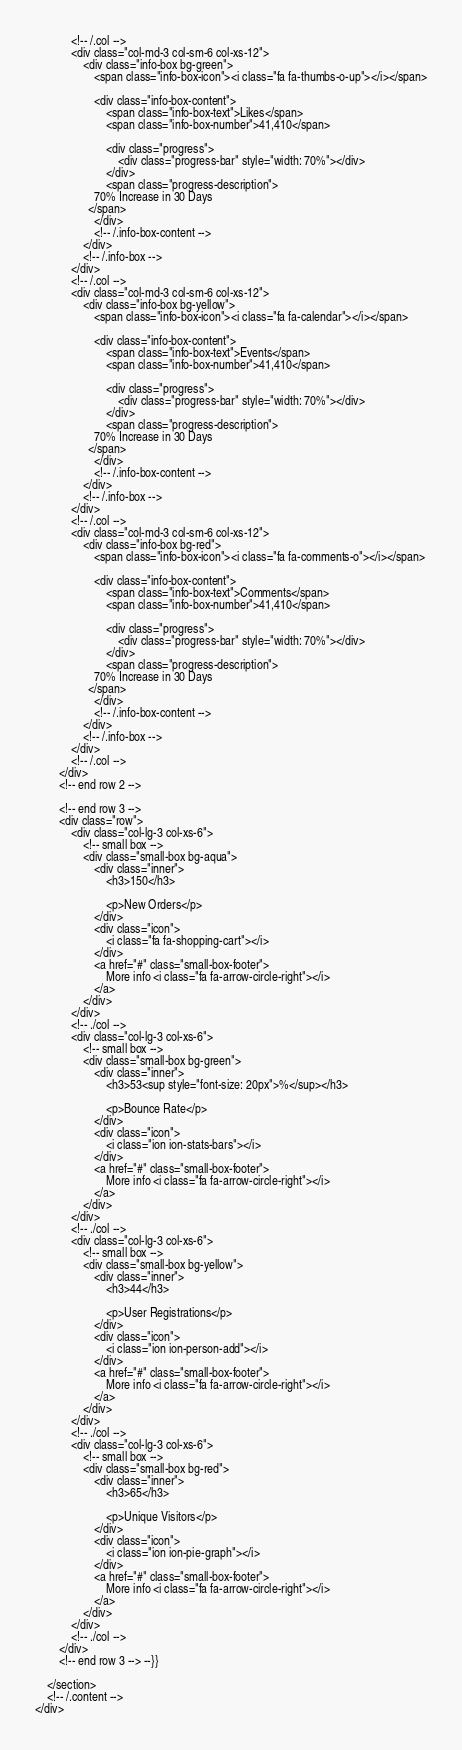<code> <loc_0><loc_0><loc_500><loc_500><_PHP_>            <!-- /.col -->
            <div class="col-md-3 col-sm-6 col-xs-12">
                <div class="info-box bg-green">
                    <span class="info-box-icon"><i class="fa fa-thumbs-o-up"></i></span>

                    <div class="info-box-content">
                        <span class="info-box-text">Likes</span>
                        <span class="info-box-number">41,410</span>

                        <div class="progress">
                            <div class="progress-bar" style="width: 70%"></div>
                        </div>
                        <span class="progress-description">
                    70% Increase in 30 Days
                  </span>
                    </div>
                    <!-- /.info-box-content -->
                </div>
                <!-- /.info-box -->
            </div>
            <!-- /.col -->
            <div class="col-md-3 col-sm-6 col-xs-12">
                <div class="info-box bg-yellow">
                    <span class="info-box-icon"><i class="fa fa-calendar"></i></span>

                    <div class="info-box-content">
                        <span class="info-box-text">Events</span>
                        <span class="info-box-number">41,410</span>

                        <div class="progress">
                            <div class="progress-bar" style="width: 70%"></div>
                        </div>
                        <span class="progress-description">
                    70% Increase in 30 Days
                  </span>
                    </div>
                    <!-- /.info-box-content -->
                </div>
                <!-- /.info-box -->
            </div>
            <!-- /.col -->
            <div class="col-md-3 col-sm-6 col-xs-12">
                <div class="info-box bg-red">
                    <span class="info-box-icon"><i class="fa fa-comments-o"></i></span>

                    <div class="info-box-content">
                        <span class="info-box-text">Comments</span>
                        <span class="info-box-number">41,410</span>

                        <div class="progress">
                            <div class="progress-bar" style="width: 70%"></div>
                        </div>
                        <span class="progress-description">
                    70% Increase in 30 Days
                  </span>
                    </div>
                    <!-- /.info-box-content -->
                </div>
                <!-- /.info-box -->
            </div>
            <!-- /.col -->
        </div>
        <!-- end row 2 -->

        <!-- end row 3 -->
        <div class="row">
            <div class="col-lg-3 col-xs-6">
                <!-- small box -->
                <div class="small-box bg-aqua">
                    <div class="inner">
                        <h3>150</h3>

                        <p>New Orders</p>
                    </div>
                    <div class="icon">
                        <i class="fa fa-shopping-cart"></i>
                    </div>
                    <a href="#" class="small-box-footer">
                        More info <i class="fa fa-arrow-circle-right"></i>
                    </a>
                </div>
            </div>
            <!-- ./col -->
            <div class="col-lg-3 col-xs-6">
                <!-- small box -->
                <div class="small-box bg-green">
                    <div class="inner">
                        <h3>53<sup style="font-size: 20px">%</sup></h3>

                        <p>Bounce Rate</p>
                    </div>
                    <div class="icon">
                        <i class="ion ion-stats-bars"></i>
                    </div>
                    <a href="#" class="small-box-footer">
                        More info <i class="fa fa-arrow-circle-right"></i>
                    </a>
                </div>
            </div>
            <!-- ./col -->
            <div class="col-lg-3 col-xs-6">
                <!-- small box -->
                <div class="small-box bg-yellow">
                    <div class="inner">
                        <h3>44</h3>

                        <p>User Registrations</p>
                    </div>
                    <div class="icon">
                        <i class="ion ion-person-add"></i>
                    </div>
                    <a href="#" class="small-box-footer">
                        More info <i class="fa fa-arrow-circle-right"></i>
                    </a>
                </div>
            </div>
            <!-- ./col -->
            <div class="col-lg-3 col-xs-6">
                <!-- small box -->
                <div class="small-box bg-red">
                    <div class="inner">
                        <h3>65</h3>

                        <p>Unique Visitors</p>
                    </div>
                    <div class="icon">
                        <i class="ion ion-pie-graph"></i>
                    </div>
                    <a href="#" class="small-box-footer">
                        More info <i class="fa fa-arrow-circle-right"></i>
                    </a>
                </div>
            </div>
            <!-- ./col -->
        </div>
        <!-- end row 3 --> --}}

    </section>
    <!-- /.content -->
</div>
</code> 